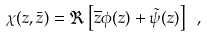Convert formula to latex. <formula><loc_0><loc_0><loc_500><loc_500>\chi ( z , \bar { z } ) = \Re \left [ \overline { z } \phi ( z ) + \tilde { \psi } ( z ) \right ] \ ,</formula> 